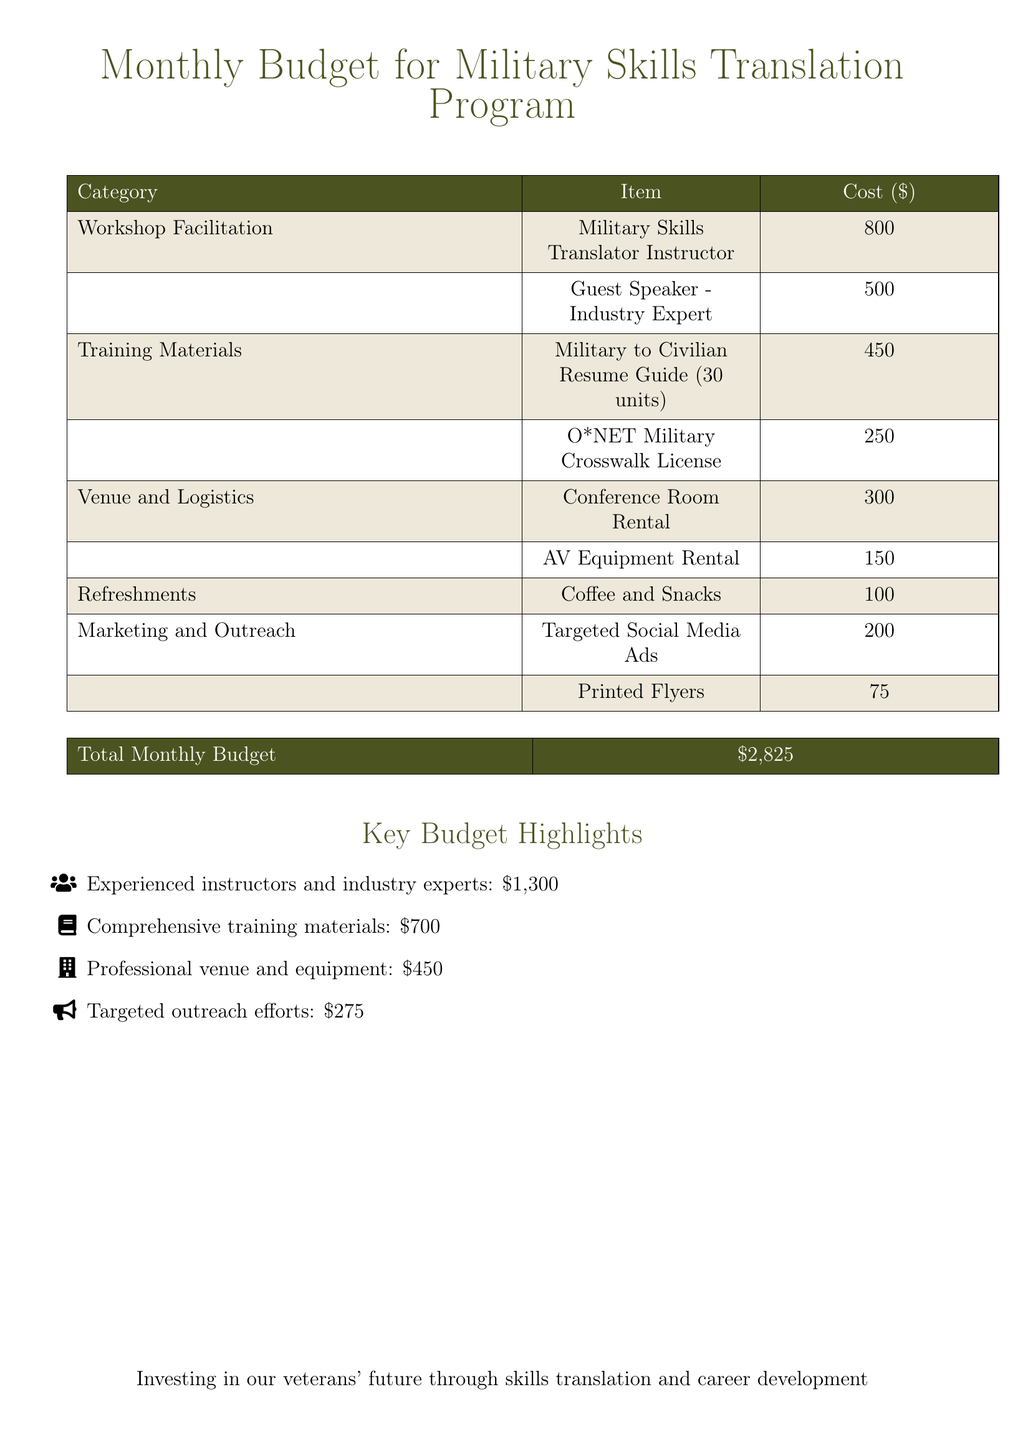what is the total monthly budget? The total monthly budget is listed at the bottom of the document.
Answer: $2,825 how much does the Military Skills Translator Instructor cost? The cost for the Military Skills Translator Instructor is found in the Workshop Facilitation section.
Answer: $800 what is the cost of the O*NET Military Crosswalk License? The O*NET Military Crosswalk License cost is specified in the Training Materials section.
Answer: $250 how much is allocated for marketing and outreach efforts? The total cost for marketing and outreach efforts is detailed in the Marketing and Outreach section.
Answer: $275 who is the guest speaker mentioned in the budget? The guest speaker is referred to in the Workshop Facilitation section, indicating their role and cost.
Answer: Industry Expert what is the cost for Conference Room Rental? The cost for Conference Room Rental is explicitly stated in the Venue and Logistics section.
Answer: $300 how much is budgeted for printed flyers? The amount budgeted for printed flyers is found in the Marketing and Outreach section.
Answer: $75 what percentage of the total budget is spent on training materials? This requires calculating the portion of the budget allocated for training materials compared to the total monthly budget.
Answer: 24.8% how many units of the Military to Civilian Resume Guide are included? The number of units for the Military to Civilian Resume Guide is mentioned in the Training Materials section.
Answer: 30 units what are the two main components of the key budget highlights section? The key budget highlights list specific funding areas for the project, discussed towards the end of the document.
Answer: Instructors and training materials 